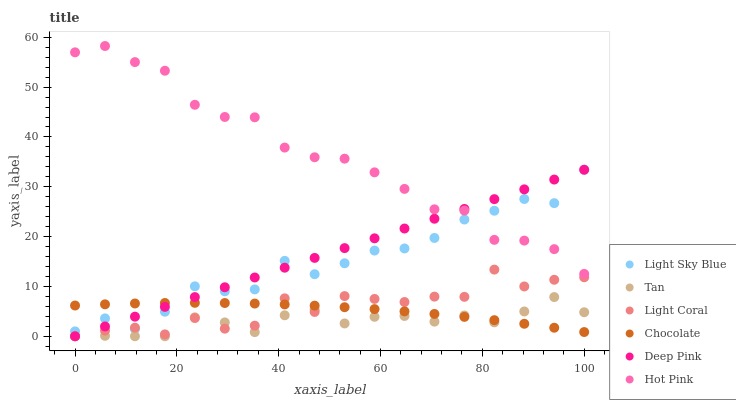Does Tan have the minimum area under the curve?
Answer yes or no. Yes. Does Hot Pink have the maximum area under the curve?
Answer yes or no. Yes. Does Chocolate have the minimum area under the curve?
Answer yes or no. No. Does Chocolate have the maximum area under the curve?
Answer yes or no. No. Is Deep Pink the smoothest?
Answer yes or no. Yes. Is Light Coral the roughest?
Answer yes or no. Yes. Is Hot Pink the smoothest?
Answer yes or no. No. Is Hot Pink the roughest?
Answer yes or no. No. Does Deep Pink have the lowest value?
Answer yes or no. Yes. Does Chocolate have the lowest value?
Answer yes or no. No. Does Hot Pink have the highest value?
Answer yes or no. Yes. Does Chocolate have the highest value?
Answer yes or no. No. Is Light Coral less than Hot Pink?
Answer yes or no. Yes. Is Light Sky Blue greater than Tan?
Answer yes or no. Yes. Does Hot Pink intersect Light Sky Blue?
Answer yes or no. Yes. Is Hot Pink less than Light Sky Blue?
Answer yes or no. No. Is Hot Pink greater than Light Sky Blue?
Answer yes or no. No. Does Light Coral intersect Hot Pink?
Answer yes or no. No. 